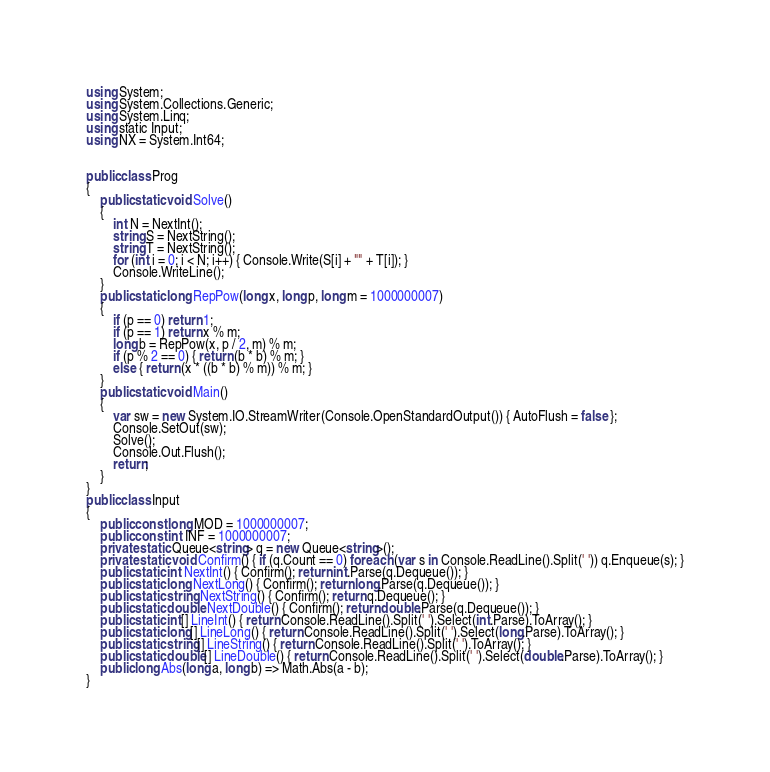Convert code to text. <code><loc_0><loc_0><loc_500><loc_500><_C#_>using System;
using System.Collections.Generic;
using System.Linq;
using static Input;
using NX = System.Int64;


public class Prog
{
    public static void Solve()
    {
        int N = NextInt();
        string S = NextString();
        string T = NextString();
        for (int i = 0; i < N; i++) { Console.Write(S[i] + "" + T[i]); }
        Console.WriteLine();
    }
    public static long RepPow(long x, long p, long m = 1000000007)
    {
        if (p == 0) return 1;
        if (p == 1) return x % m;
        long b = RepPow(x, p / 2, m) % m;
        if (p % 2 == 0) { return (b * b) % m; }
        else { return (x * ((b * b) % m)) % m; }
    }
    public static void Main()
    {
        var sw = new System.IO.StreamWriter(Console.OpenStandardOutput()) { AutoFlush = false };
        Console.SetOut(sw);
        Solve();
        Console.Out.Flush();
        return;
    }
}
public class Input
{
    public const long MOD = 1000000007;
    public const int INF = 1000000007;
    private static Queue<string> q = new Queue<string>();
    private static void Confirm() { if (q.Count == 0) foreach (var s in Console.ReadLine().Split(' ')) q.Enqueue(s); }
    public static int NextInt() { Confirm(); return int.Parse(q.Dequeue()); }
    public static long NextLong() { Confirm(); return long.Parse(q.Dequeue()); }
    public static string NextString() { Confirm(); return q.Dequeue(); }
    public static double NextDouble() { Confirm(); return double.Parse(q.Dequeue()); }
    public static int[] LineInt() { return Console.ReadLine().Split(' ').Select(int.Parse).ToArray(); }
    public static long[] LineLong() { return Console.ReadLine().Split(' ').Select(long.Parse).ToArray(); }
    public static string[] LineString() { return Console.ReadLine().Split(' ').ToArray(); }
    public static double[] LineDouble() { return Console.ReadLine().Split(' ').Select(double.Parse).ToArray(); }
    public long Abs(long a, long b) => Math.Abs(a - b);
}
</code> 